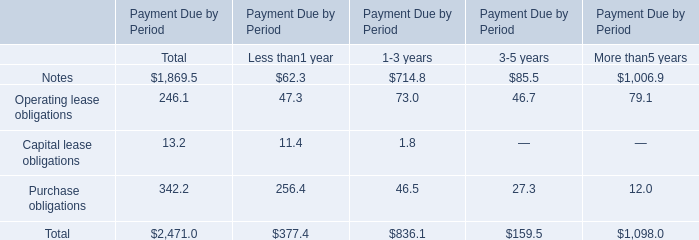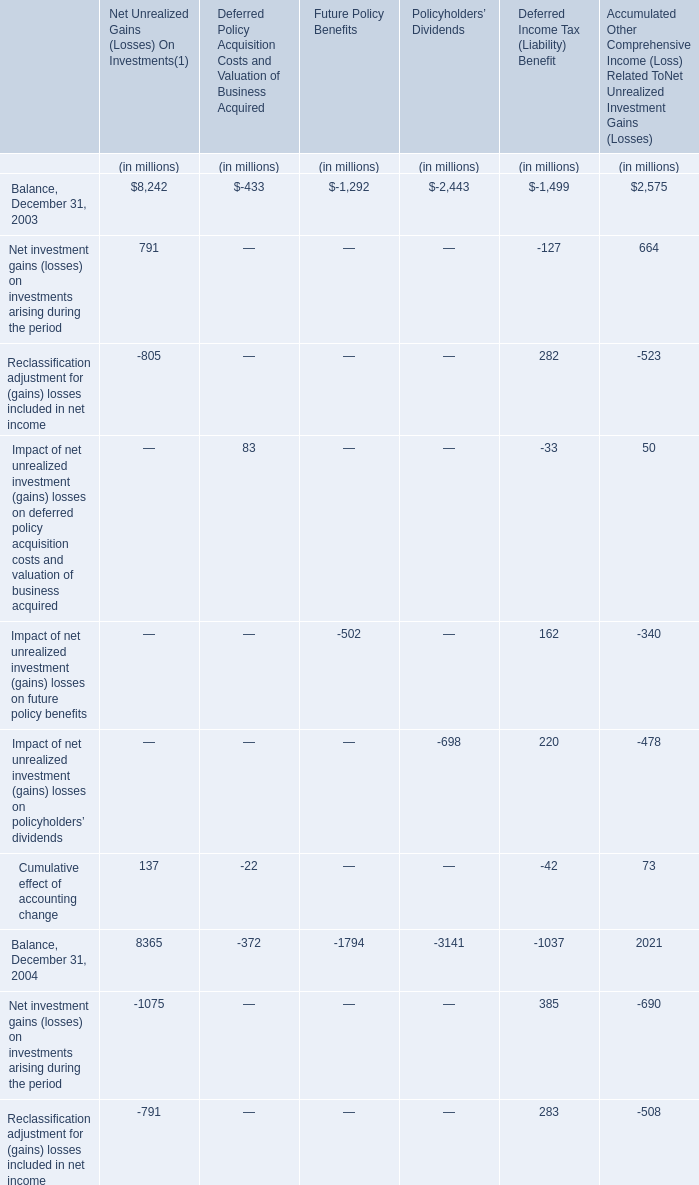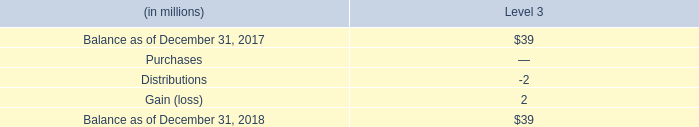what was the ratio of the pension trust assets for 2017 to 2018 
Computations: (480 / 415)
Answer: 1.15663. 